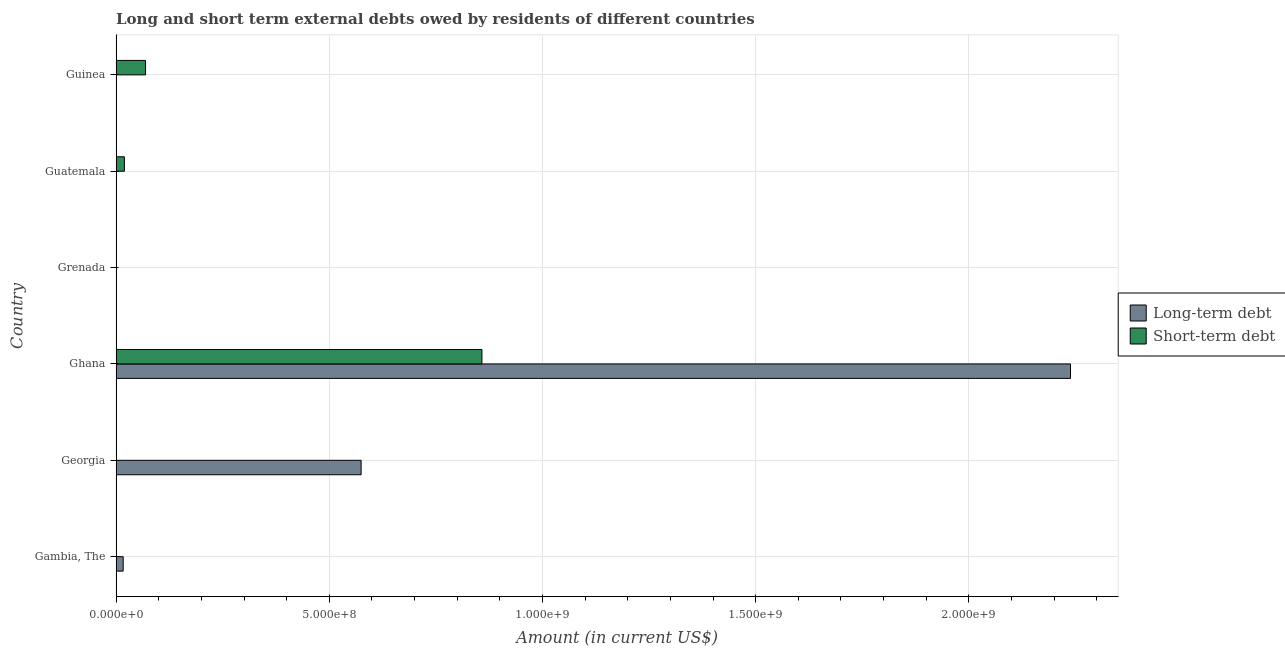Are the number of bars per tick equal to the number of legend labels?
Offer a terse response. No. Are the number of bars on each tick of the Y-axis equal?
Make the answer very short. No. How many bars are there on the 6th tick from the top?
Provide a short and direct response. 1. How many bars are there on the 3rd tick from the bottom?
Your answer should be compact. 2. What is the short-term debts owed by residents in Guatemala?
Provide a succinct answer. 1.94e+07. Across all countries, what is the maximum short-term debts owed by residents?
Provide a short and direct response. 8.58e+08. Across all countries, what is the minimum short-term debts owed by residents?
Offer a very short reply. 0. In which country was the short-term debts owed by residents maximum?
Offer a very short reply. Ghana. What is the total long-term debts owed by residents in the graph?
Provide a short and direct response. 2.83e+09. What is the difference between the short-term debts owed by residents in Ghana and that in Guatemala?
Your answer should be compact. 8.39e+08. What is the difference between the long-term debts owed by residents in Gambia, The and the short-term debts owed by residents in Ghana?
Keep it short and to the point. -8.41e+08. What is the average long-term debts owed by residents per country?
Provide a succinct answer. 4.72e+08. What is the difference between the long-term debts owed by residents and short-term debts owed by residents in Ghana?
Ensure brevity in your answer.  1.38e+09. What is the ratio of the short-term debts owed by residents in Ghana to that in Guinea?
Ensure brevity in your answer.  12.44. Is the short-term debts owed by residents in Guatemala less than that in Guinea?
Your response must be concise. Yes. What is the difference between the highest and the second highest short-term debts owed by residents?
Provide a succinct answer. 7.89e+08. What is the difference between the highest and the lowest long-term debts owed by residents?
Keep it short and to the point. 2.24e+09. How many bars are there?
Provide a succinct answer. 6. How many countries are there in the graph?
Offer a terse response. 6. What is the difference between two consecutive major ticks on the X-axis?
Offer a terse response. 5.00e+08. Are the values on the major ticks of X-axis written in scientific E-notation?
Ensure brevity in your answer.  Yes. Does the graph contain grids?
Offer a terse response. Yes. How many legend labels are there?
Ensure brevity in your answer.  2. How are the legend labels stacked?
Provide a succinct answer. Vertical. What is the title of the graph?
Keep it short and to the point. Long and short term external debts owed by residents of different countries. What is the label or title of the X-axis?
Your response must be concise. Amount (in current US$). What is the Amount (in current US$) of Long-term debt in Gambia, The?
Your answer should be compact. 1.65e+07. What is the Amount (in current US$) in Long-term debt in Georgia?
Your answer should be compact. 5.75e+08. What is the Amount (in current US$) of Short-term debt in Georgia?
Your answer should be compact. 0. What is the Amount (in current US$) in Long-term debt in Ghana?
Give a very brief answer. 2.24e+09. What is the Amount (in current US$) of Short-term debt in Ghana?
Your response must be concise. 8.58e+08. What is the Amount (in current US$) of Long-term debt in Grenada?
Provide a succinct answer. 0. What is the Amount (in current US$) of Short-term debt in Grenada?
Offer a very short reply. 0. What is the Amount (in current US$) of Long-term debt in Guatemala?
Provide a short and direct response. 0. What is the Amount (in current US$) of Short-term debt in Guatemala?
Give a very brief answer. 1.94e+07. What is the Amount (in current US$) of Long-term debt in Guinea?
Give a very brief answer. 0. What is the Amount (in current US$) of Short-term debt in Guinea?
Offer a terse response. 6.90e+07. Across all countries, what is the maximum Amount (in current US$) in Long-term debt?
Offer a very short reply. 2.24e+09. Across all countries, what is the maximum Amount (in current US$) in Short-term debt?
Provide a short and direct response. 8.58e+08. Across all countries, what is the minimum Amount (in current US$) of Short-term debt?
Your answer should be compact. 0. What is the total Amount (in current US$) of Long-term debt in the graph?
Offer a terse response. 2.83e+09. What is the total Amount (in current US$) in Short-term debt in the graph?
Ensure brevity in your answer.  9.46e+08. What is the difference between the Amount (in current US$) of Long-term debt in Gambia, The and that in Georgia?
Provide a succinct answer. -5.58e+08. What is the difference between the Amount (in current US$) of Long-term debt in Gambia, The and that in Ghana?
Provide a short and direct response. -2.22e+09. What is the difference between the Amount (in current US$) of Long-term debt in Georgia and that in Ghana?
Your answer should be compact. -1.66e+09. What is the difference between the Amount (in current US$) in Short-term debt in Ghana and that in Guatemala?
Ensure brevity in your answer.  8.39e+08. What is the difference between the Amount (in current US$) of Short-term debt in Ghana and that in Guinea?
Your answer should be very brief. 7.89e+08. What is the difference between the Amount (in current US$) of Short-term debt in Guatemala and that in Guinea?
Your answer should be compact. -4.96e+07. What is the difference between the Amount (in current US$) in Long-term debt in Gambia, The and the Amount (in current US$) in Short-term debt in Ghana?
Provide a succinct answer. -8.41e+08. What is the difference between the Amount (in current US$) in Long-term debt in Gambia, The and the Amount (in current US$) in Short-term debt in Guatemala?
Your response must be concise. -2.86e+06. What is the difference between the Amount (in current US$) in Long-term debt in Gambia, The and the Amount (in current US$) in Short-term debt in Guinea?
Offer a very short reply. -5.25e+07. What is the difference between the Amount (in current US$) of Long-term debt in Georgia and the Amount (in current US$) of Short-term debt in Ghana?
Offer a terse response. -2.83e+08. What is the difference between the Amount (in current US$) in Long-term debt in Georgia and the Amount (in current US$) in Short-term debt in Guatemala?
Offer a very short reply. 5.55e+08. What is the difference between the Amount (in current US$) of Long-term debt in Georgia and the Amount (in current US$) of Short-term debt in Guinea?
Your response must be concise. 5.06e+08. What is the difference between the Amount (in current US$) of Long-term debt in Ghana and the Amount (in current US$) of Short-term debt in Guatemala?
Your answer should be very brief. 2.22e+09. What is the difference between the Amount (in current US$) in Long-term debt in Ghana and the Amount (in current US$) in Short-term debt in Guinea?
Your response must be concise. 2.17e+09. What is the average Amount (in current US$) in Long-term debt per country?
Your response must be concise. 4.72e+08. What is the average Amount (in current US$) of Short-term debt per country?
Ensure brevity in your answer.  1.58e+08. What is the difference between the Amount (in current US$) of Long-term debt and Amount (in current US$) of Short-term debt in Ghana?
Your answer should be compact. 1.38e+09. What is the ratio of the Amount (in current US$) in Long-term debt in Gambia, The to that in Georgia?
Give a very brief answer. 0.03. What is the ratio of the Amount (in current US$) of Long-term debt in Gambia, The to that in Ghana?
Your answer should be very brief. 0.01. What is the ratio of the Amount (in current US$) in Long-term debt in Georgia to that in Ghana?
Make the answer very short. 0.26. What is the ratio of the Amount (in current US$) in Short-term debt in Ghana to that in Guatemala?
Your response must be concise. 44.23. What is the ratio of the Amount (in current US$) in Short-term debt in Ghana to that in Guinea?
Offer a very short reply. 12.43. What is the ratio of the Amount (in current US$) of Short-term debt in Guatemala to that in Guinea?
Offer a terse response. 0.28. What is the difference between the highest and the second highest Amount (in current US$) in Long-term debt?
Your answer should be compact. 1.66e+09. What is the difference between the highest and the second highest Amount (in current US$) of Short-term debt?
Provide a short and direct response. 7.89e+08. What is the difference between the highest and the lowest Amount (in current US$) of Long-term debt?
Make the answer very short. 2.24e+09. What is the difference between the highest and the lowest Amount (in current US$) in Short-term debt?
Your answer should be compact. 8.58e+08. 